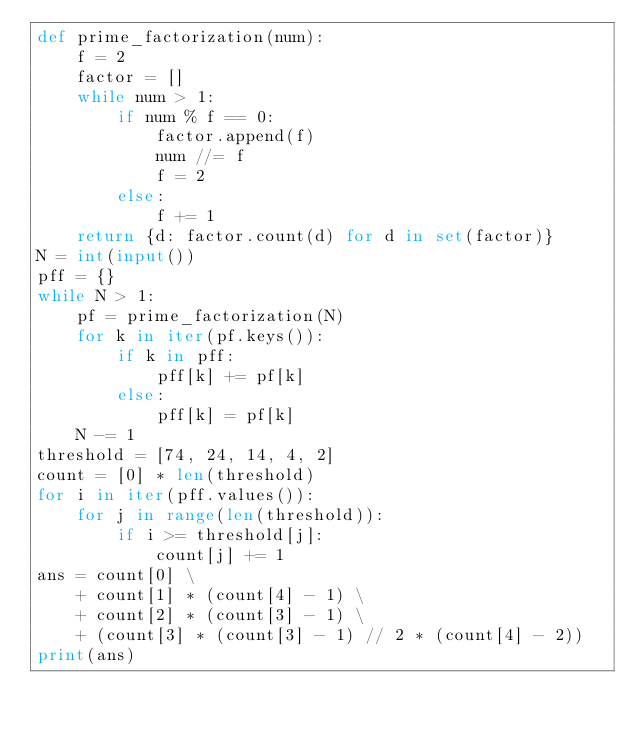<code> <loc_0><loc_0><loc_500><loc_500><_Python_>def prime_factorization(num):
    f = 2
    factor = []
    while num > 1:
        if num % f == 0:
            factor.append(f)
            num //= f
            f = 2
        else:
            f += 1
    return {d: factor.count(d) for d in set(factor)}
N = int(input())
pff = {}
while N > 1:
    pf = prime_factorization(N)
    for k in iter(pf.keys()):
        if k in pff:
            pff[k] += pf[k]
        else:
            pff[k] = pf[k]
    N -= 1
threshold = [74, 24, 14, 4, 2]
count = [0] * len(threshold)
for i in iter(pff.values()):
    for j in range(len(threshold)):
        if i >= threshold[j]:
            count[j] += 1
ans = count[0] \
    + count[1] * (count[4] - 1) \
    + count[2] * (count[3] - 1) \
    + (count[3] * (count[3] - 1) // 2 * (count[4] - 2))
print(ans)</code> 